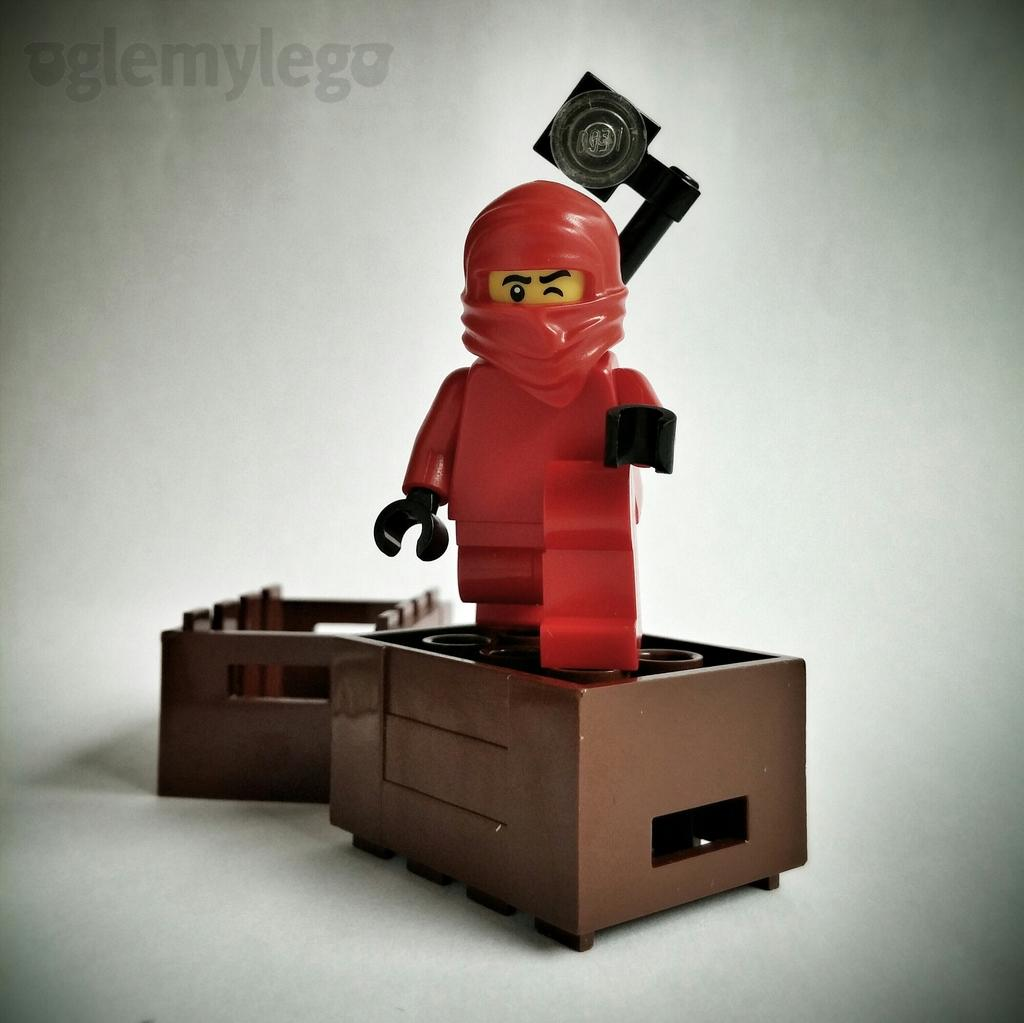What object is the main focus of the image? There is a toy in the image. What color is the background of the image? The background of the image is white. Can you see a goose in the image? There is no goose present in the image. What type of hammer is being used in the image? There is no hammer present in the image. 